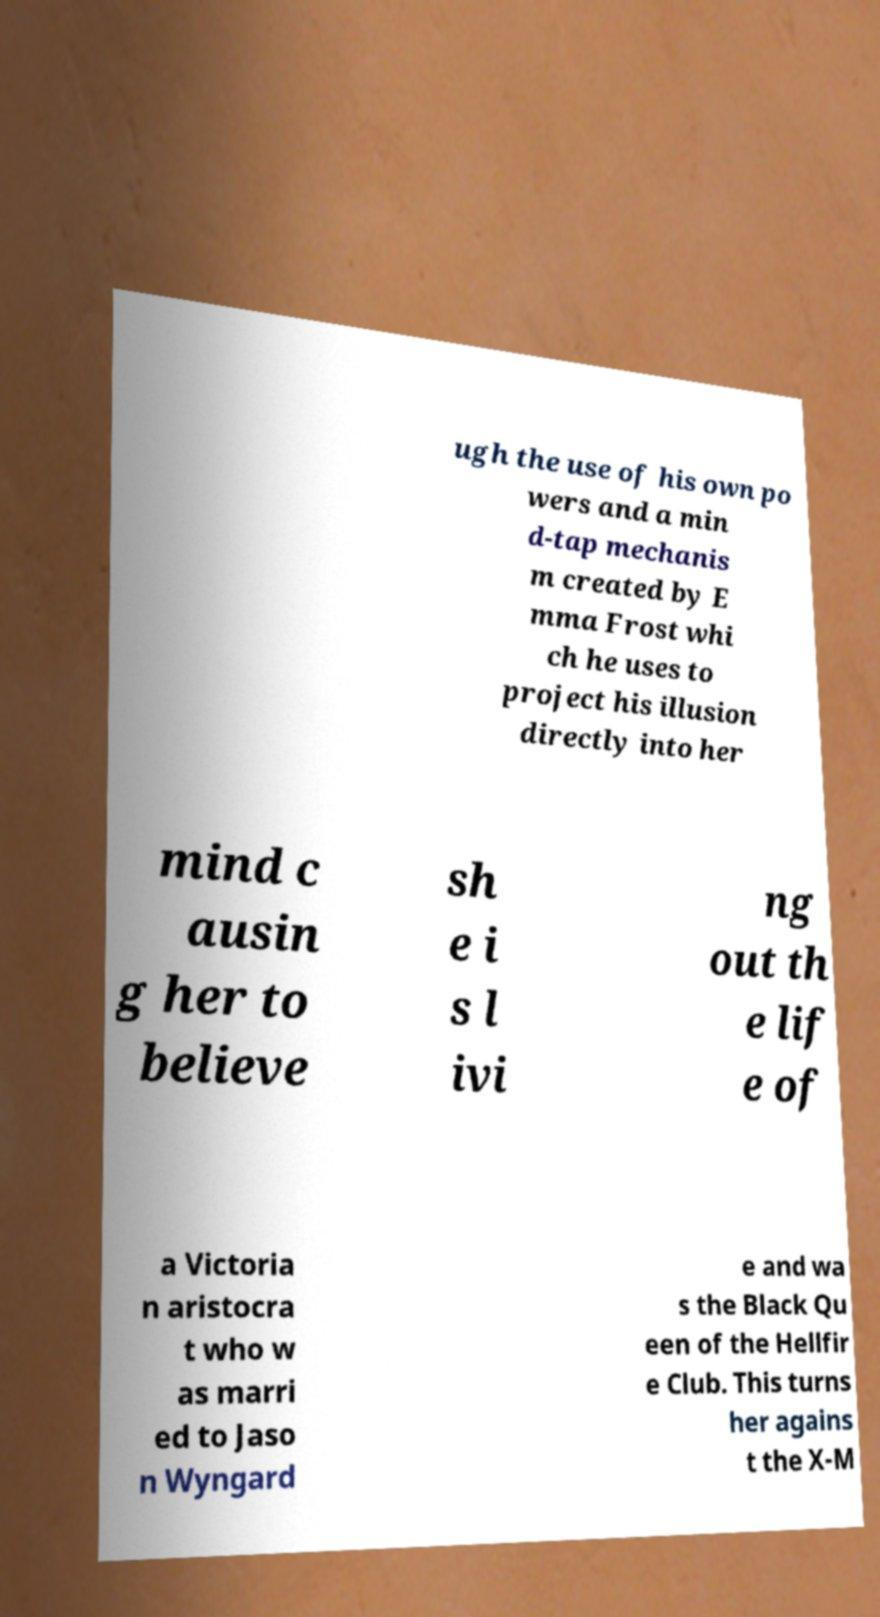I need the written content from this picture converted into text. Can you do that? ugh the use of his own po wers and a min d-tap mechanis m created by E mma Frost whi ch he uses to project his illusion directly into her mind c ausin g her to believe sh e i s l ivi ng out th e lif e of a Victoria n aristocra t who w as marri ed to Jaso n Wyngard e and wa s the Black Qu een of the Hellfir e Club. This turns her agains t the X-M 